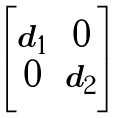Convert formula to latex. <formula><loc_0><loc_0><loc_500><loc_500>\begin{bmatrix} d _ { 1 } & 0 \\ 0 & d _ { 2 } \end{bmatrix}</formula> 